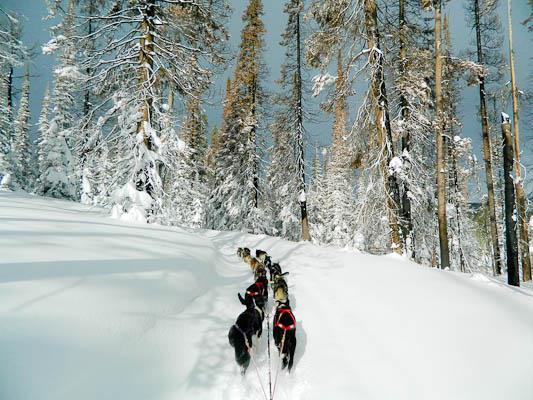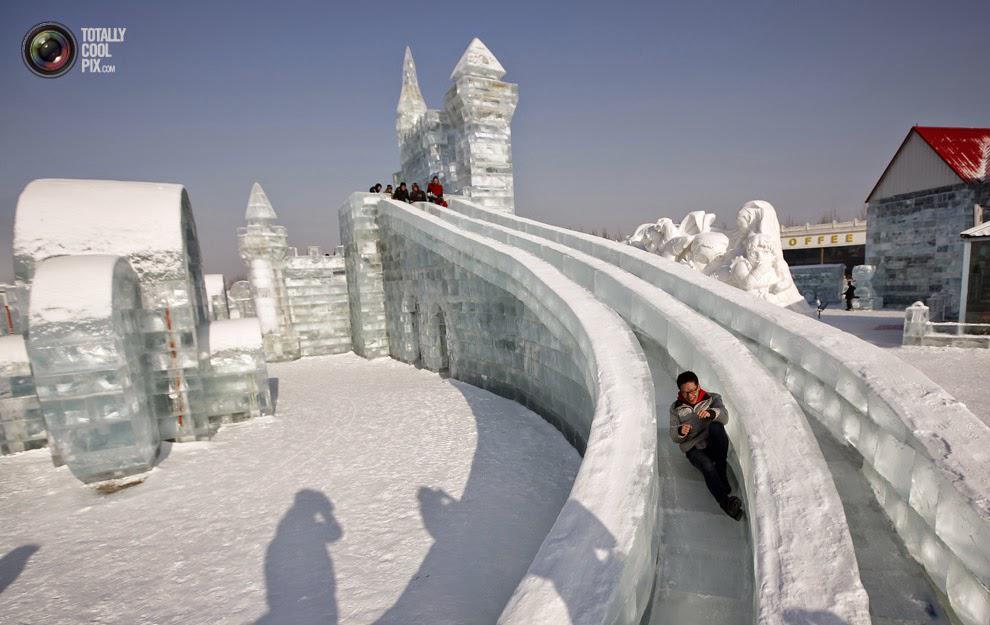The first image is the image on the left, the second image is the image on the right. Considering the images on both sides, is "The left image shows a sled dog team moving horizontally to the right, and the right image shows a sled dog team on a path to the right of log cabins." valid? Answer yes or no. No. The first image is the image on the left, the second image is the image on the right. Examine the images to the left and right. Is the description "Both images contain dogs moving forward." accurate? Answer yes or no. No. 